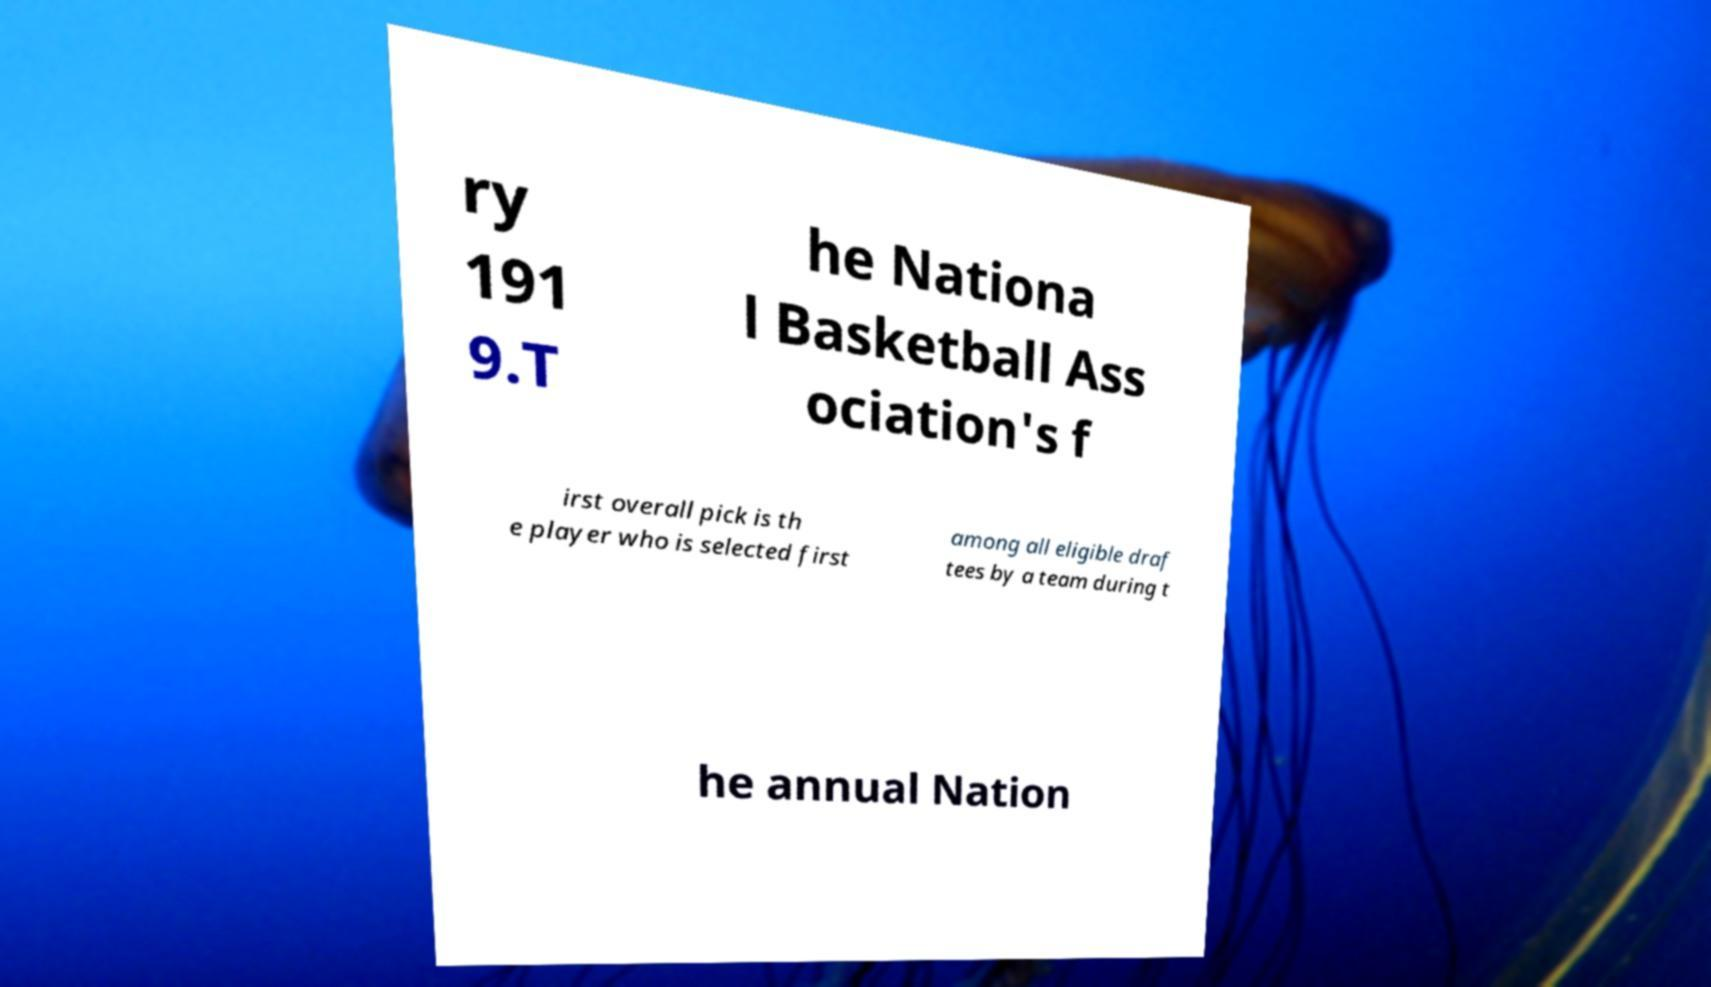Can you read and provide the text displayed in the image?This photo seems to have some interesting text. Can you extract and type it out for me? ry 191 9.T he Nationa l Basketball Ass ociation's f irst overall pick is th e player who is selected first among all eligible draf tees by a team during t he annual Nation 